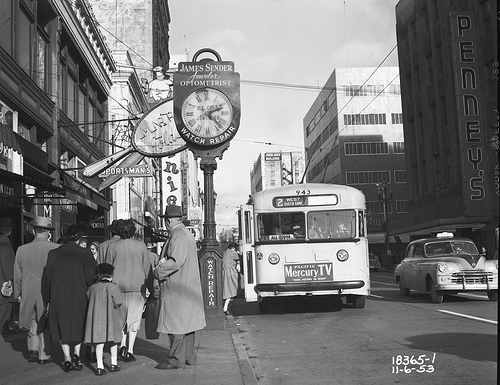Read all the text in this image. WATCH REPAIR TV 2 SENDER PEnnEY'S 943 53 6 18365 Mercury OPTOM JAMES nie WATCH REPAIR M SPORTSMAN'S 